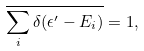Convert formula to latex. <formula><loc_0><loc_0><loc_500><loc_500>\overline { \sum _ { i } \delta ( \epsilon ^ { \prime } - E _ { i } ) } = 1 ,</formula> 